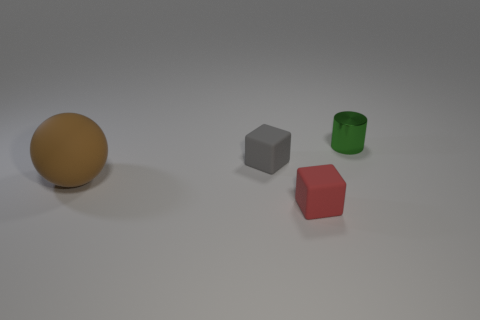Are there more matte things that are in front of the big brown matte object than cylinders that are to the right of the tiny metallic thing?
Your answer should be compact. Yes. There is a object right of the tiny thing in front of the small block that is behind the brown object; what is its size?
Provide a succinct answer. Small. Is there a large rubber cube of the same color as the sphere?
Provide a succinct answer. No. How many small cyan metallic cubes are there?
Give a very brief answer. 0. The tiny object that is behind the cube on the left side of the small cube in front of the large brown object is made of what material?
Provide a succinct answer. Metal. Is there a red thing that has the same material as the gray block?
Provide a short and direct response. Yes. Does the cylinder have the same material as the small red block?
Make the answer very short. No. How many cubes are either tiny red rubber things or tiny green metal things?
Your response must be concise. 1. What color is the ball that is made of the same material as the red object?
Offer a terse response. Brown. Is the number of small things less than the number of things?
Provide a short and direct response. Yes. 